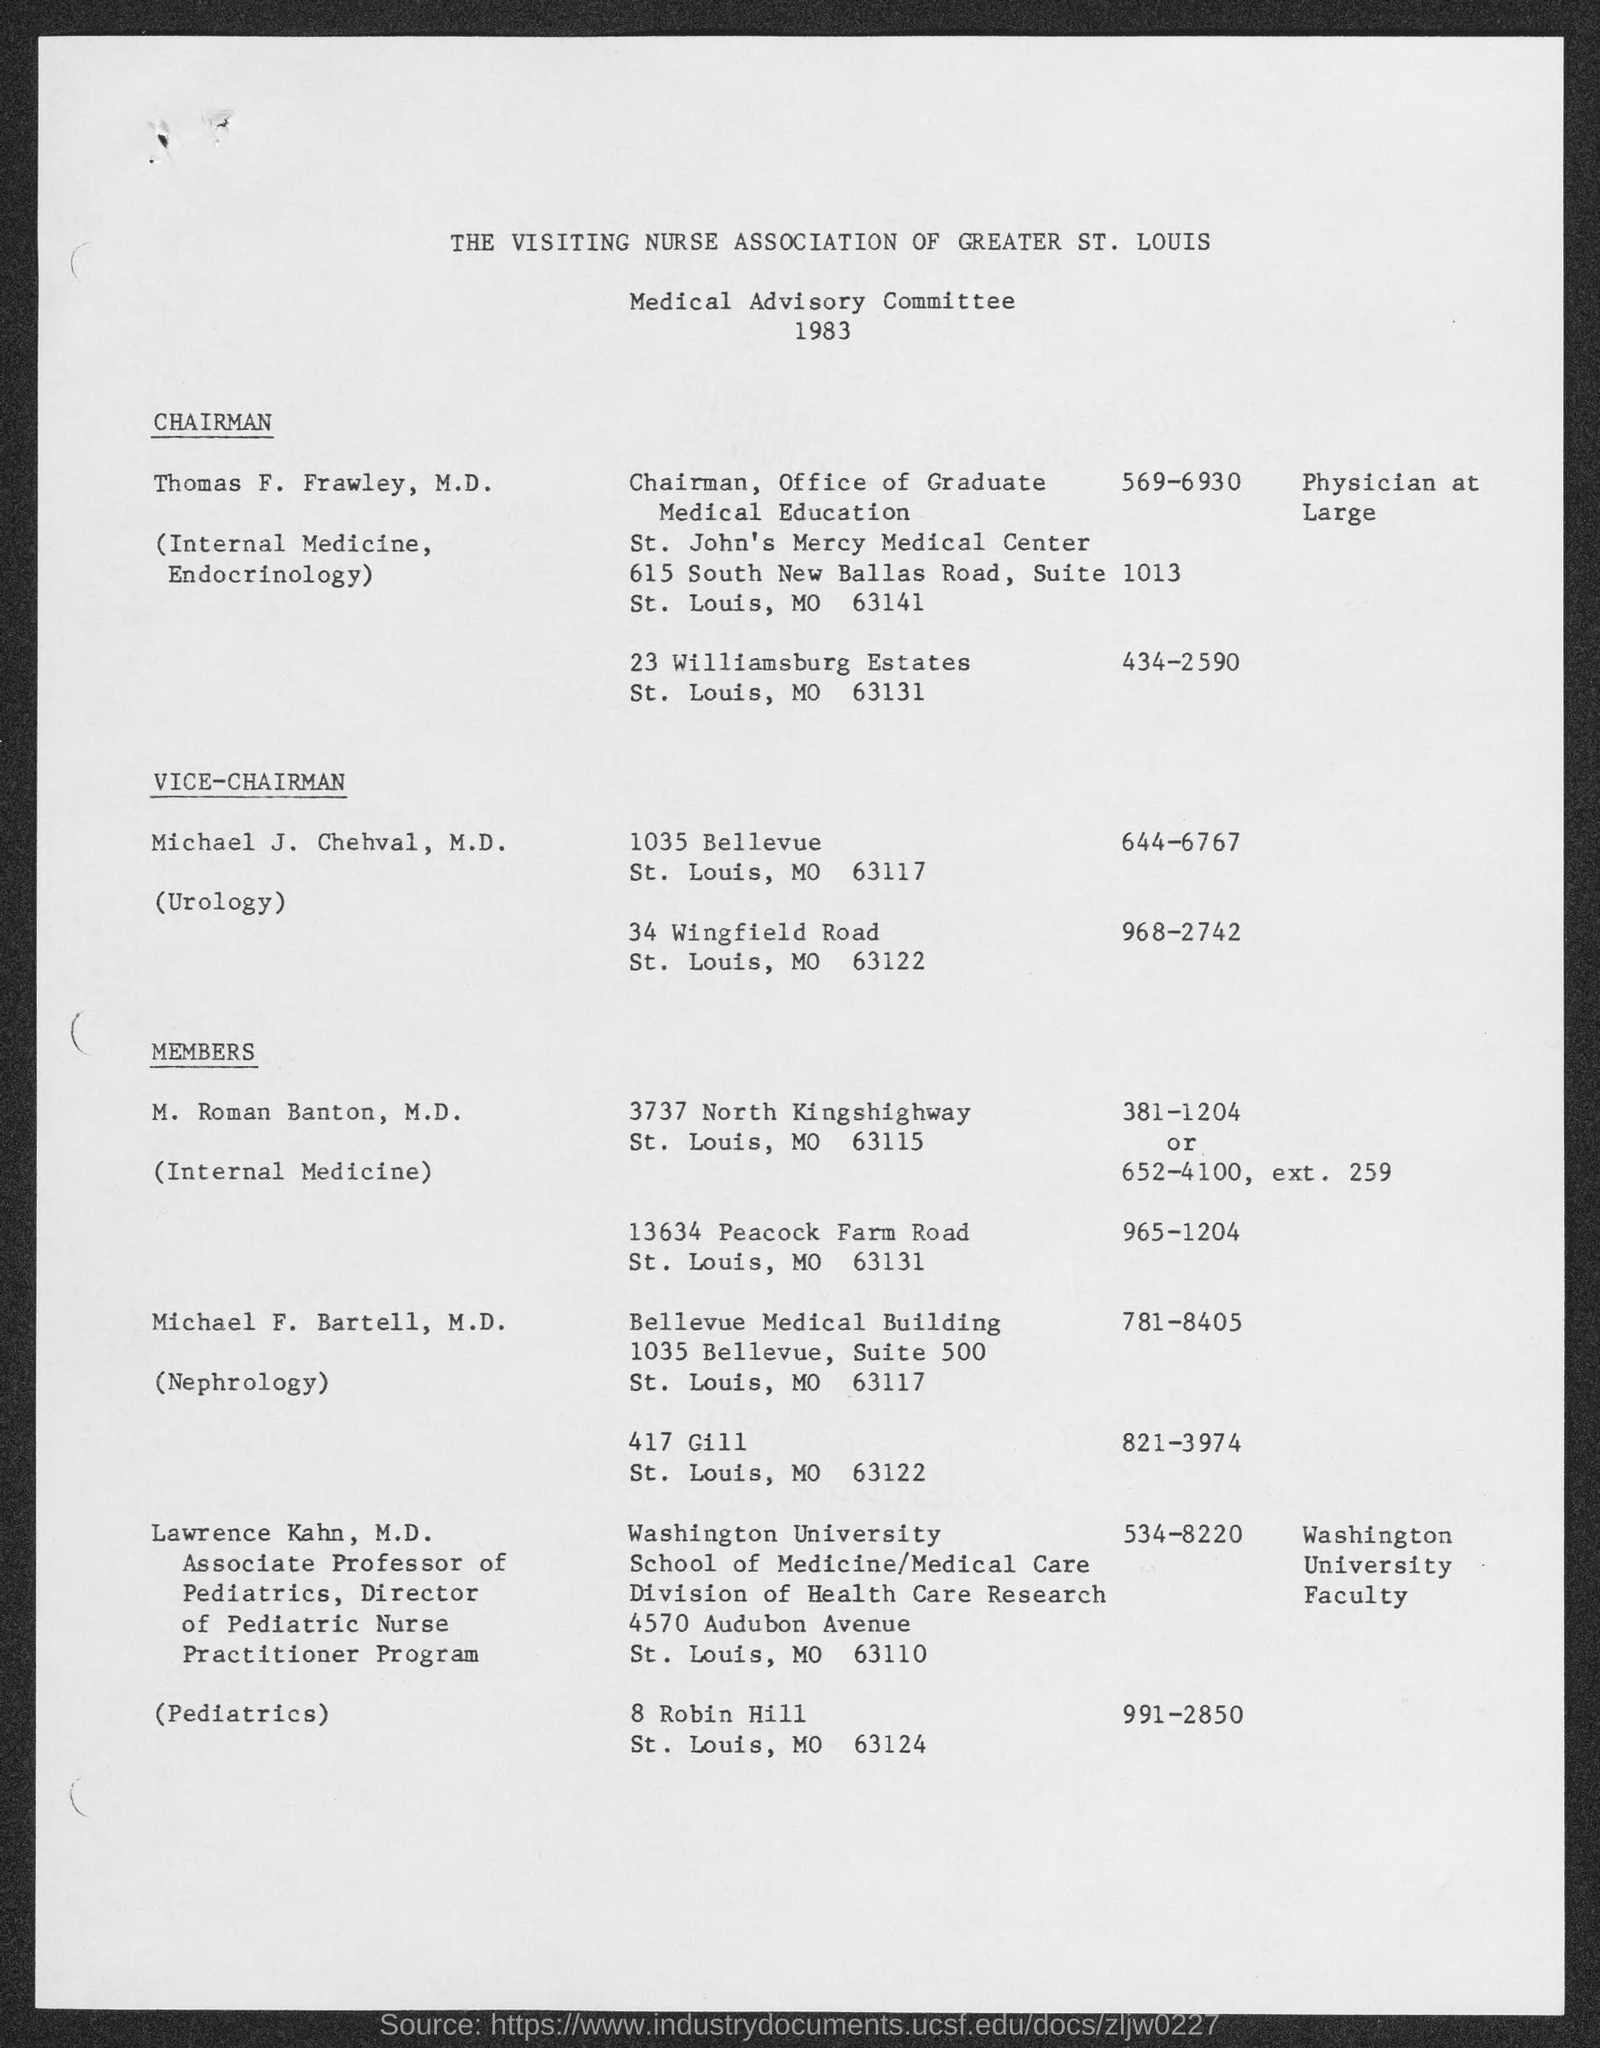Point out several critical features in this image. The Medical Advisory Committee was established in 1983. Thomas F. Frawley, M.D., is the chairman of the Office of Graduate Medical Education. Michael J. Chehval, M.D. is the Vice-Chairman. The phone number of Michael J. Chehval, M.D. at 1035 Bellevue is 644-6767. 